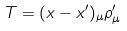<formula> <loc_0><loc_0><loc_500><loc_500>T = ( x - x ^ { \prime } ) _ { \mu } \rho _ { \mu } ^ { \prime }</formula> 